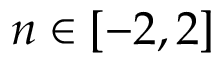<formula> <loc_0><loc_0><loc_500><loc_500>n \in [ - 2 , 2 ]</formula> 